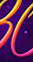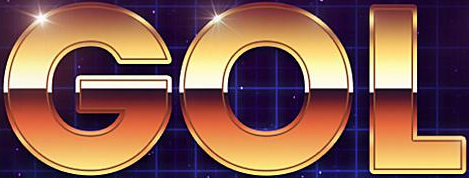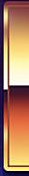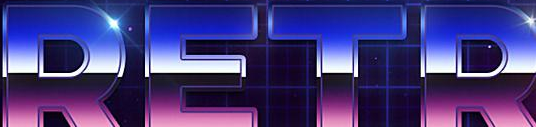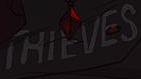Read the text content from these images in order, separated by a semicolon. #; GOL; #; RETR; THIEVES 